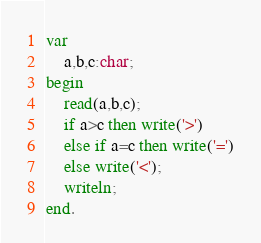Convert code to text. <code><loc_0><loc_0><loc_500><loc_500><_Pascal_>var
    a,b,c:char;
begin
    read(a,b,c);
    if a>c then write('>')
    else if a=c then write('=')
    else write('<');
    writeln;
end.</code> 